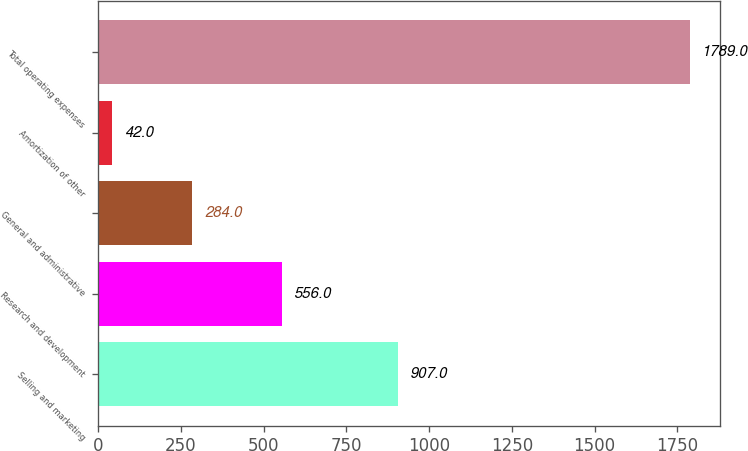<chart> <loc_0><loc_0><loc_500><loc_500><bar_chart><fcel>Selling and marketing<fcel>Research and development<fcel>General and administrative<fcel>Amortization of other<fcel>Total operating expenses<nl><fcel>907<fcel>556<fcel>284<fcel>42<fcel>1789<nl></chart> 